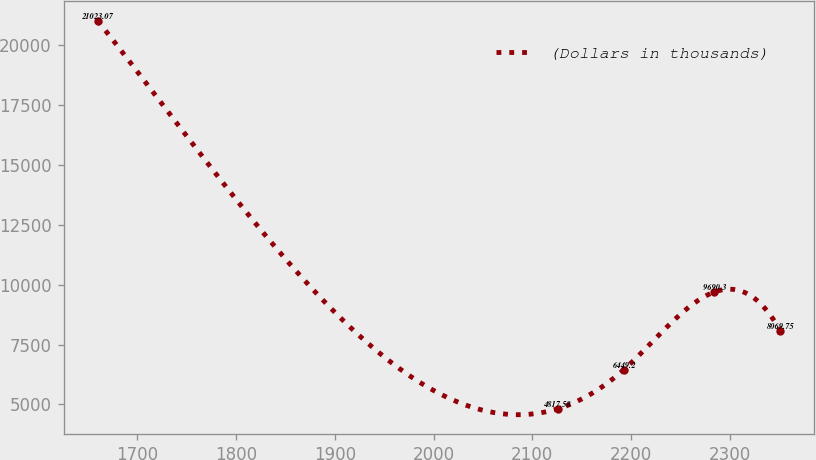Convert chart. <chart><loc_0><loc_0><loc_500><loc_500><line_chart><ecel><fcel>(Dollars in thousands)<nl><fcel>1659.85<fcel>21023.1<nl><fcel>2125.71<fcel>4817.58<nl><fcel>2192.69<fcel>6449.2<nl><fcel>2284.26<fcel>9690.3<nl><fcel>2351.24<fcel>8069.75<nl></chart> 